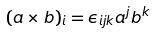<formula> <loc_0><loc_0><loc_500><loc_500>( a \times b ) _ { i } = \epsilon _ { i j k } a ^ { j } b ^ { k }</formula> 